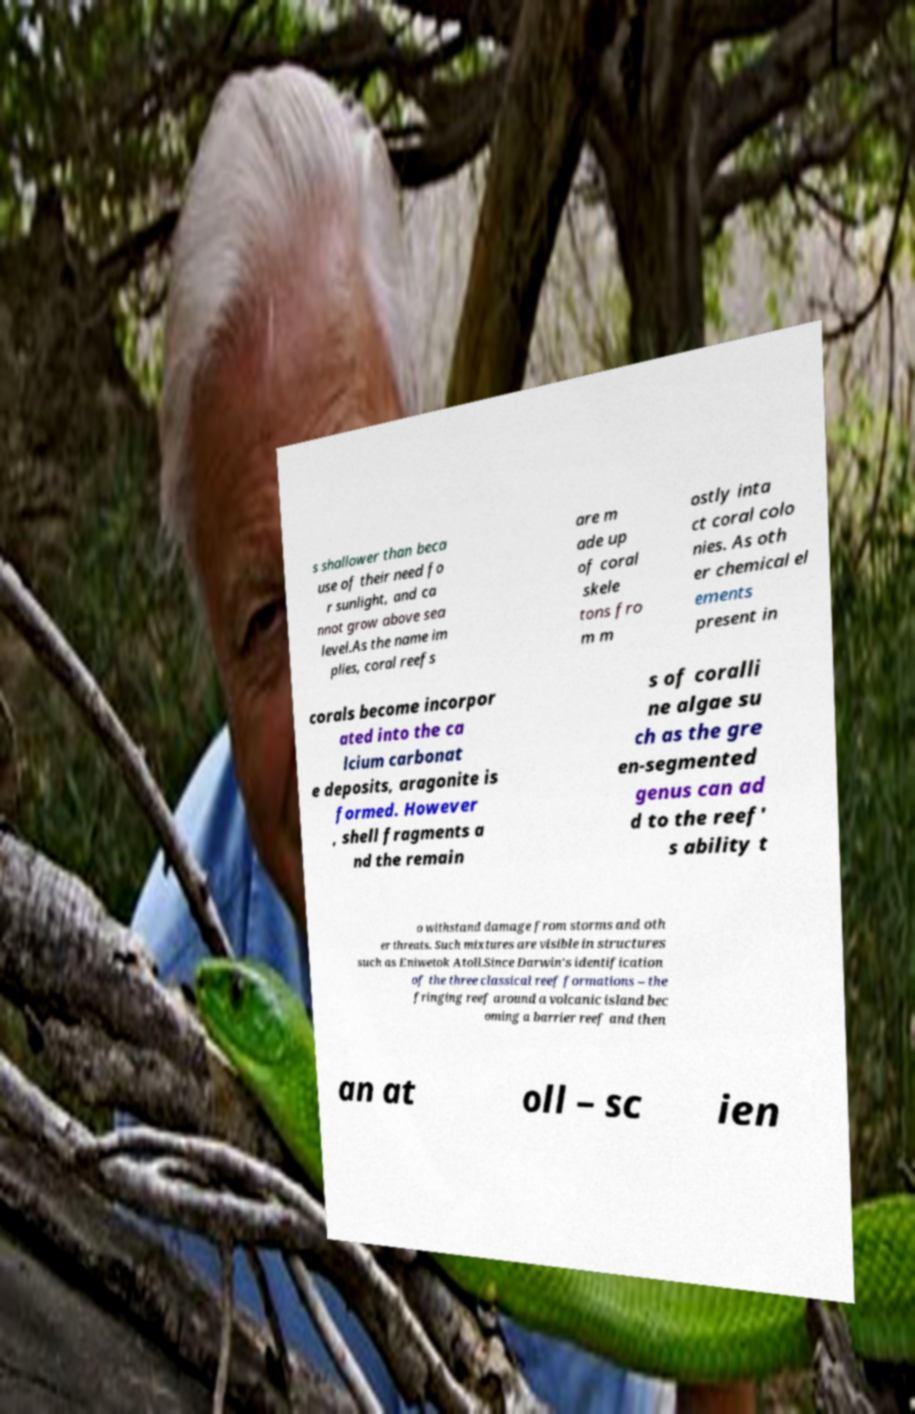Could you extract and type out the text from this image? s shallower than beca use of their need fo r sunlight, and ca nnot grow above sea level.As the name im plies, coral reefs are m ade up of coral skele tons fro m m ostly inta ct coral colo nies. As oth er chemical el ements present in corals become incorpor ated into the ca lcium carbonat e deposits, aragonite is formed. However , shell fragments a nd the remain s of coralli ne algae su ch as the gre en-segmented genus can ad d to the reef' s ability t o withstand damage from storms and oth er threats. Such mixtures are visible in structures such as Eniwetok Atoll.Since Darwin's identification of the three classical reef formations – the fringing reef around a volcanic island bec oming a barrier reef and then an at oll – sc ien 